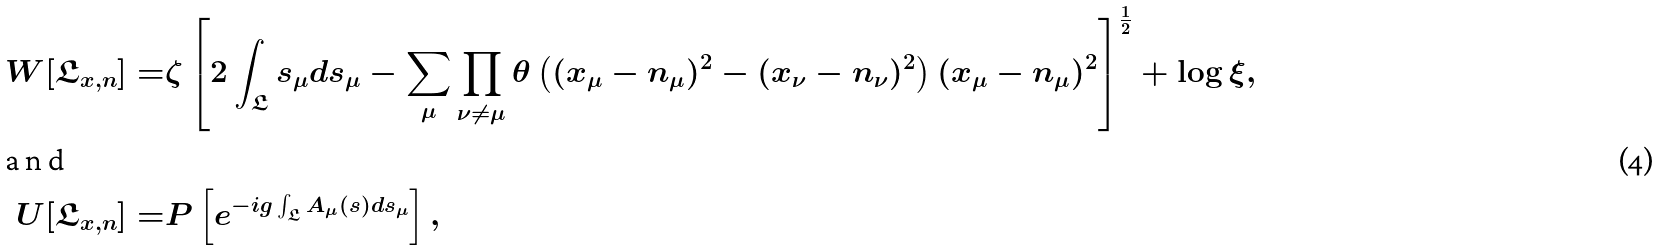Convert formula to latex. <formula><loc_0><loc_0><loc_500><loc_500>W [ \mathfrak { L } _ { x , n } ] = & \zeta \left [ 2 \int _ { \mathfrak { L } } { s } _ { \mu } d { s } _ { \mu } - \sum _ { \mu } \prod _ { \nu \neq \mu } \theta \left ( ( x _ { \mu } - n _ { \mu } ) ^ { 2 } - ( x _ { \nu } - n _ { \nu } ) ^ { 2 } \right ) ( x _ { \mu } - n _ { \mu } ) ^ { 2 } \right ] ^ { \frac { 1 } { 2 } } + \log \xi , \\ \intertext { a n d } U [ \mathfrak { L } _ { x , n } ] = & P \left [ e ^ { - i g \int _ { \mathfrak { L } } A _ { \mu } ( { s } ) d { s } _ { \mu } } \right ] ,</formula> 